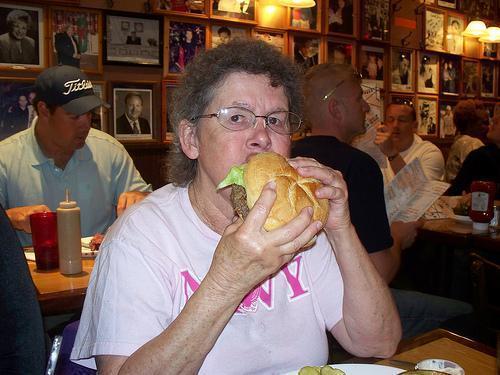How many people are wearing a hat?
Give a very brief answer. 1. 